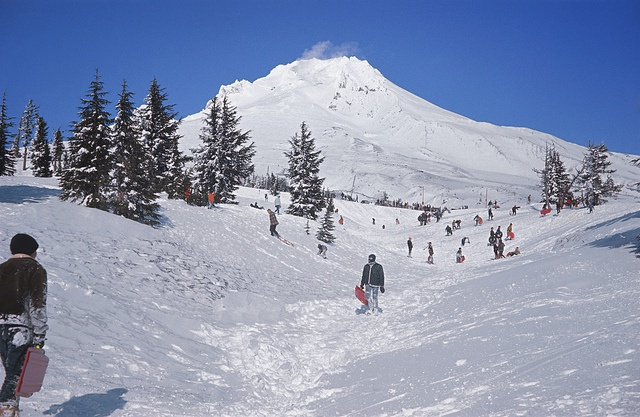Describe the objects in this image and their specific colors. I can see people in blue, black, gray, and darkgray tones, people in blue, lightgray, darkgray, gray, and black tones, snowboard in blue, gray, maroon, darkgray, and purple tones, people in blue, gray, darkgray, darkblue, and black tones, and snowboard in blue, brown, and darkgray tones in this image. 